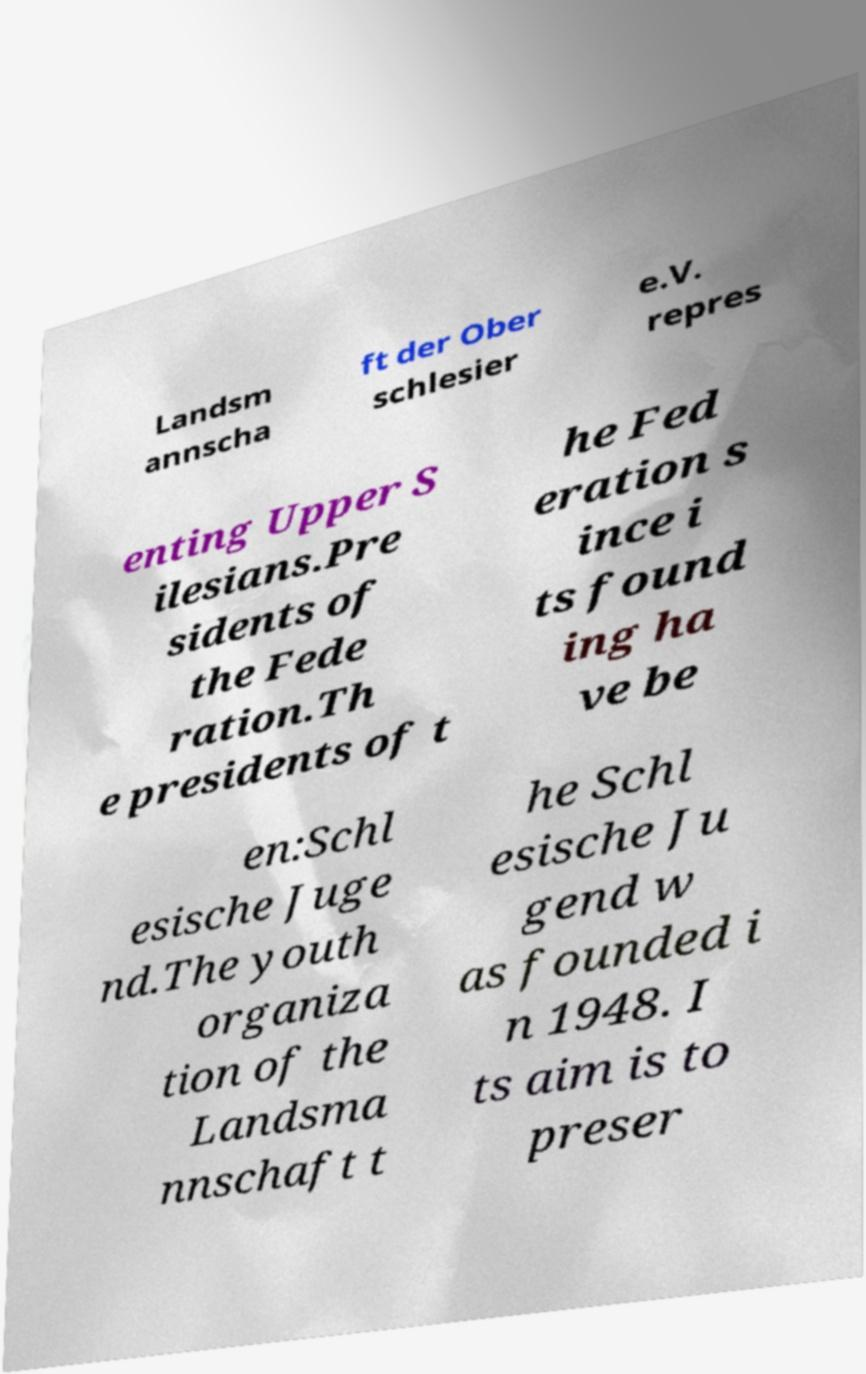There's text embedded in this image that I need extracted. Can you transcribe it verbatim? Landsm annscha ft der Ober schlesier e.V. repres enting Upper S ilesians.Pre sidents of the Fede ration.Th e presidents of t he Fed eration s ince i ts found ing ha ve be en:Schl esische Juge nd.The youth organiza tion of the Landsma nnschaft t he Schl esische Ju gend w as founded i n 1948. I ts aim is to preser 